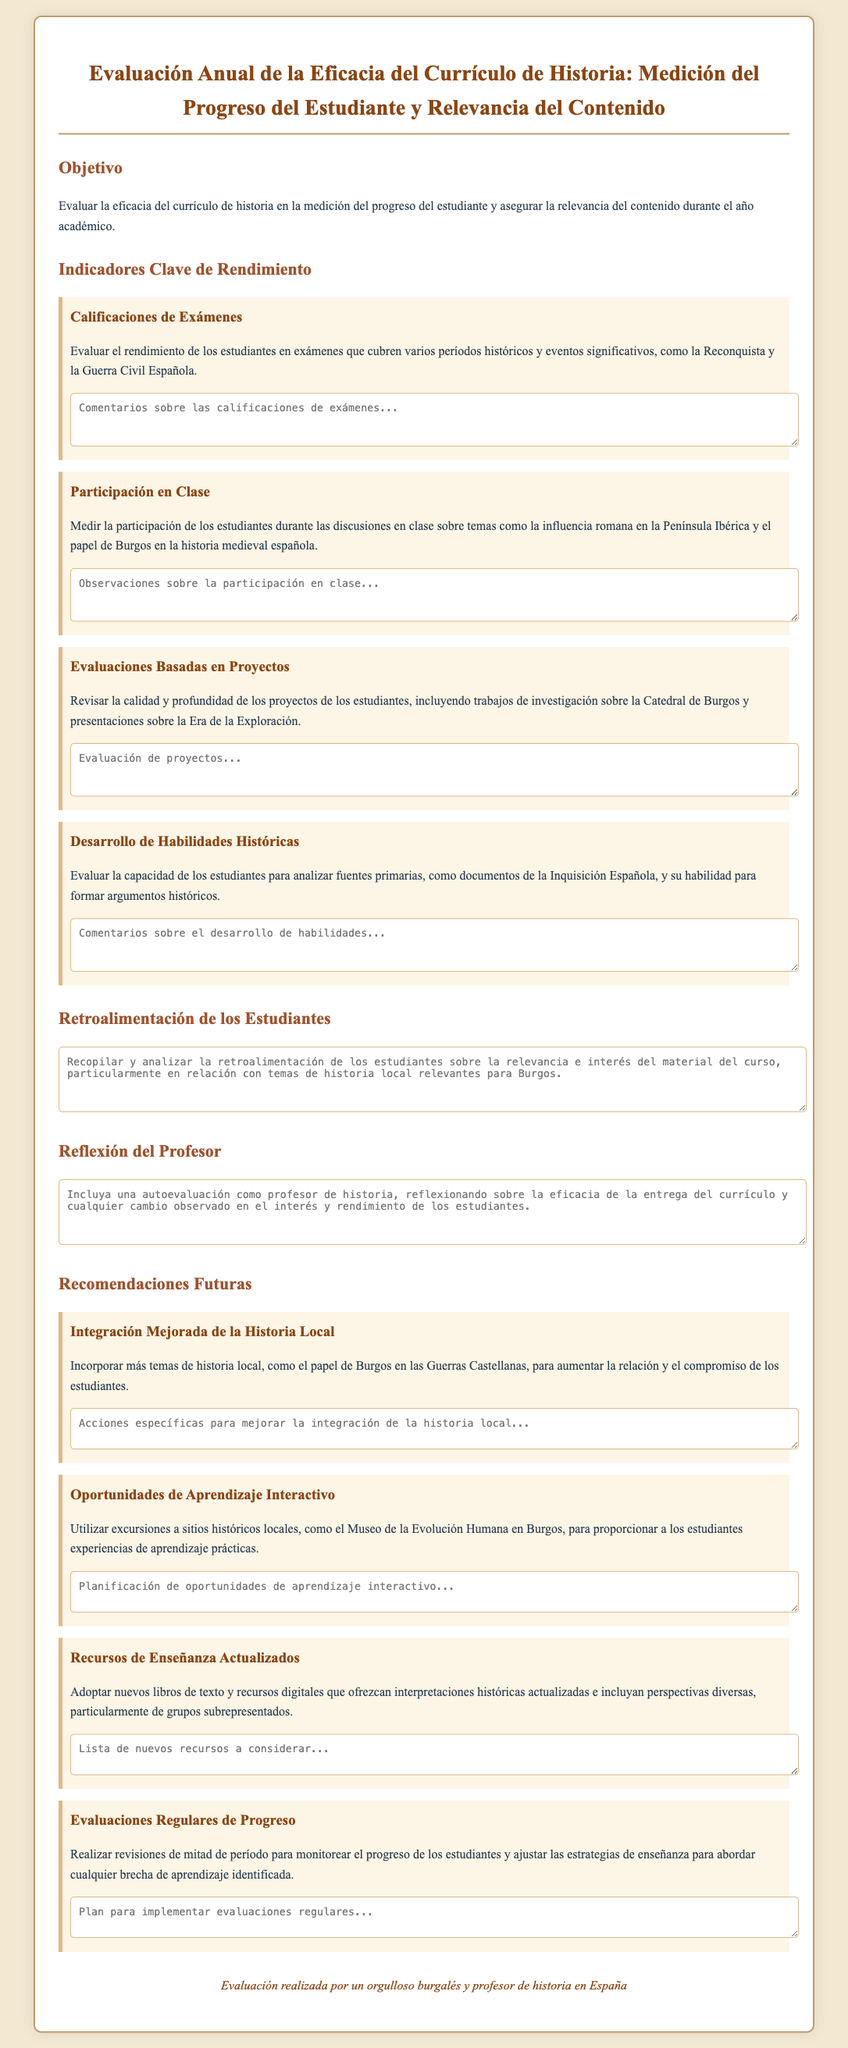What is the title of the document? The title of the document is provided in the header section which outlines the main focus of the appraisal form.
Answer: Evaluación Anual de la Eficacia del Currículo de Historia: Medición del Progreso del Estudiante y Relevancia del Contenido What are the key performance indicators (KPI) mentioned? The KPIs are listed under "Indicadores Clave de Rendimiento" and describe different areas of assessment for the history curriculum.
Answer: Calificaciones de Exámenes, Participación en Clase, Evaluaciones Basadas en Proyectos, Desarrollo de Habilidades Históricas Which historical event is specifically mentioned in the context of student projects? The document mentions distinct subjects of study that include significant projects for students, particularly in historical context.
Answer: Catedral de Burgos What is the recommendation related to local history integration? The document provides specific suggestions aimed at improving student engagement through relevant topics, particularly linked to the community.
Answer: Incorporar más temas de historia local How many recommendations are listed in the document? The document describes various recommended actions in the future section aiming for better curriculum implementation.
Answer: Cuatro 